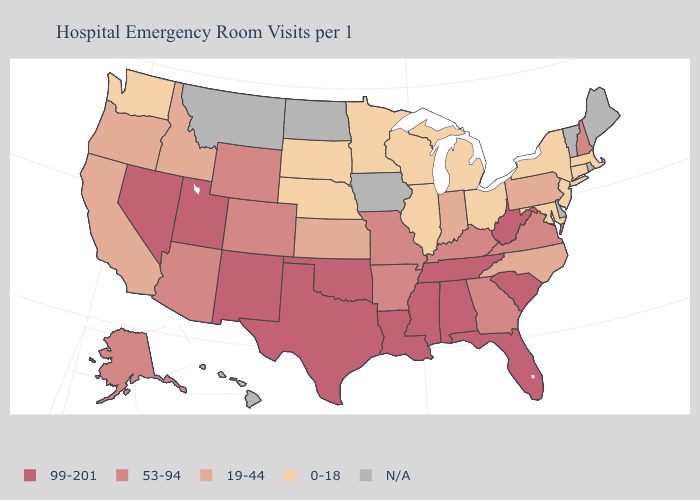Does the map have missing data?
Concise answer only. Yes. Name the states that have a value in the range 99-201?
Be succinct. Alabama, Florida, Louisiana, Mississippi, Nevada, New Mexico, Oklahoma, South Carolina, Tennessee, Texas, Utah, West Virginia. What is the value of Ohio?
Concise answer only. 0-18. Is the legend a continuous bar?
Answer briefly. No. Among the states that border Louisiana , does Texas have the highest value?
Short answer required. Yes. Does the first symbol in the legend represent the smallest category?
Concise answer only. No. Name the states that have a value in the range 0-18?
Keep it brief. Connecticut, Illinois, Maryland, Massachusetts, Michigan, Minnesota, Nebraska, New Jersey, New York, Ohio, South Dakota, Washington, Wisconsin. What is the value of Idaho?
Give a very brief answer. 19-44. Name the states that have a value in the range 19-44?
Write a very short answer. California, Idaho, Indiana, Kansas, North Carolina, Oregon, Pennsylvania. Does Nevada have the highest value in the West?
Quick response, please. Yes. Name the states that have a value in the range 53-94?
Concise answer only. Alaska, Arizona, Arkansas, Colorado, Georgia, Kentucky, Missouri, New Hampshire, Virginia, Wyoming. Name the states that have a value in the range 19-44?
Concise answer only. California, Idaho, Indiana, Kansas, North Carolina, Oregon, Pennsylvania. What is the value of Nevada?
Keep it brief. 99-201. Which states have the lowest value in the West?
Be succinct. Washington. 